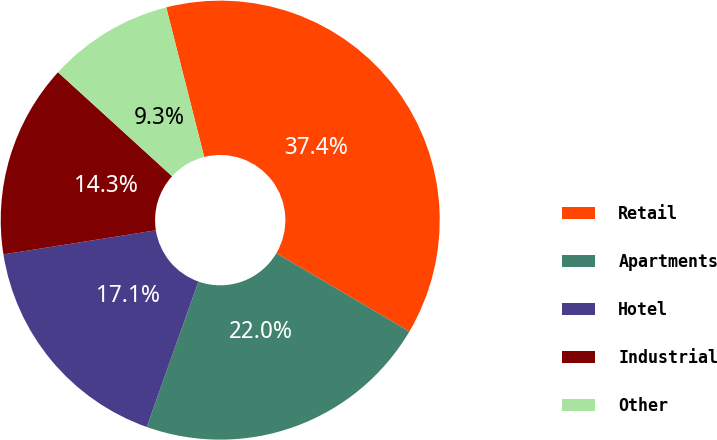Convert chart to OTSL. <chart><loc_0><loc_0><loc_500><loc_500><pie_chart><fcel>Retail<fcel>Apartments<fcel>Hotel<fcel>Industrial<fcel>Other<nl><fcel>37.42%<fcel>21.97%<fcel>17.07%<fcel>14.26%<fcel>9.28%<nl></chart> 